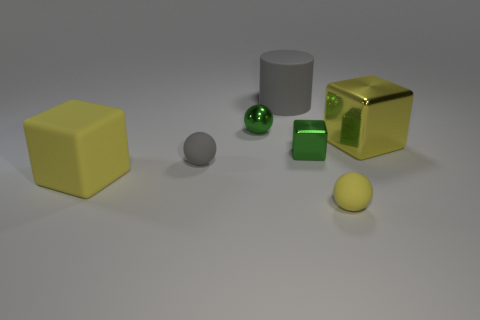Are there any yellow metal objects of the same size as the yellow metallic cube?
Provide a short and direct response. No. There is a large block behind the large yellow object in front of the tiny cube; what is its material?
Offer a terse response. Metal. What number of tiny objects are the same color as the matte cylinder?
Give a very brief answer. 1. There is a tiny object that is the same material as the tiny green block; what shape is it?
Your response must be concise. Sphere. How big is the yellow cube in front of the large shiny object?
Your answer should be compact. Large. Is the number of green objects that are on the right side of the shiny ball the same as the number of spheres that are behind the small yellow matte thing?
Ensure brevity in your answer.  No. The small ball in front of the yellow object that is on the left side of the gray object behind the green ball is what color?
Give a very brief answer. Yellow. How many things are both right of the shiny ball and in front of the small metal sphere?
Offer a terse response. 3. There is a rubber cylinder that is right of the tiny gray object; is its color the same as the matte ball that is to the left of the matte cylinder?
Ensure brevity in your answer.  Yes. There is another green metallic thing that is the same shape as the large shiny object; what is its size?
Offer a terse response. Small. 